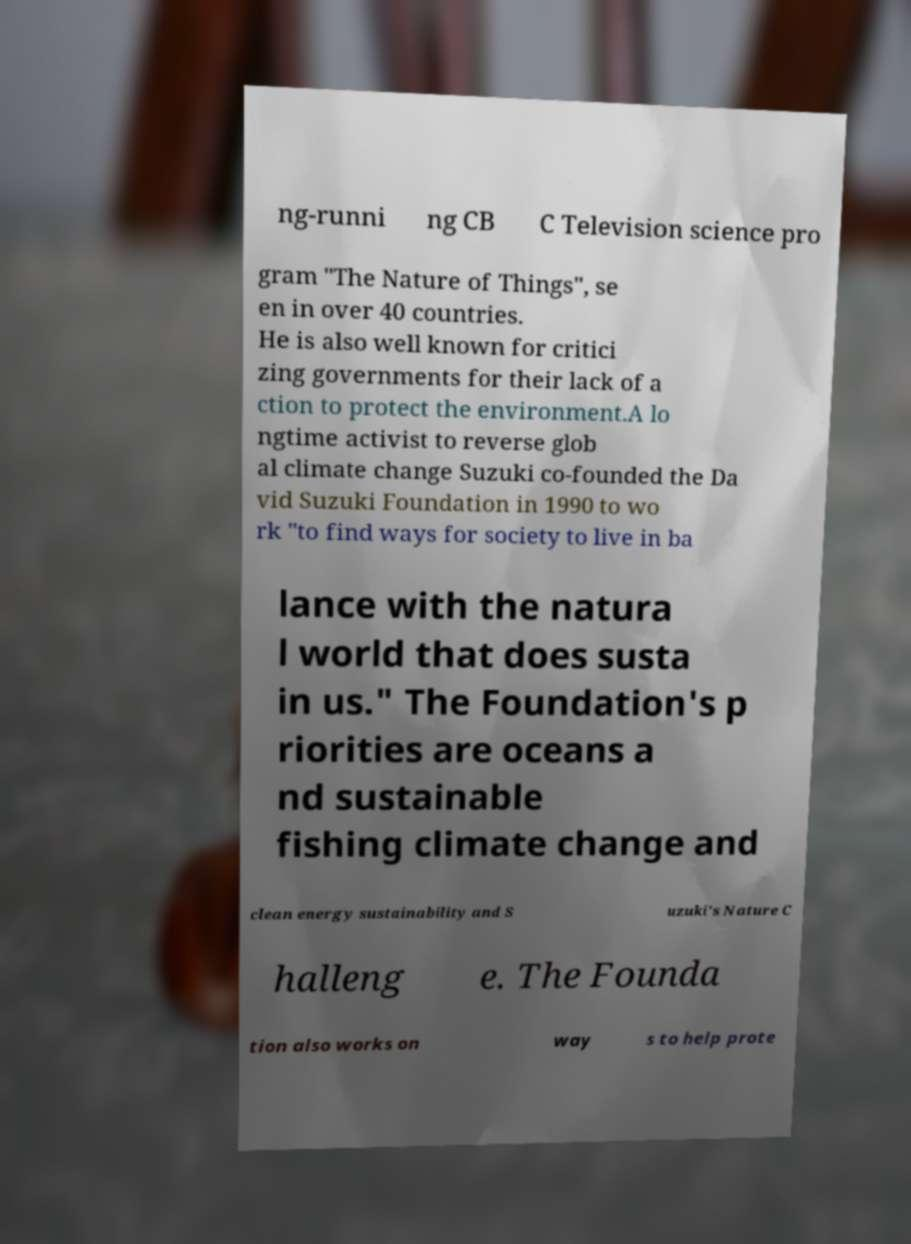There's text embedded in this image that I need extracted. Can you transcribe it verbatim? ng-runni ng CB C Television science pro gram "The Nature of Things", se en in over 40 countries. He is also well known for critici zing governments for their lack of a ction to protect the environment.A lo ngtime activist to reverse glob al climate change Suzuki co-founded the Da vid Suzuki Foundation in 1990 to wo rk "to find ways for society to live in ba lance with the natura l world that does susta in us." The Foundation's p riorities are oceans a nd sustainable fishing climate change and clean energy sustainability and S uzuki's Nature C halleng e. The Founda tion also works on way s to help prote 